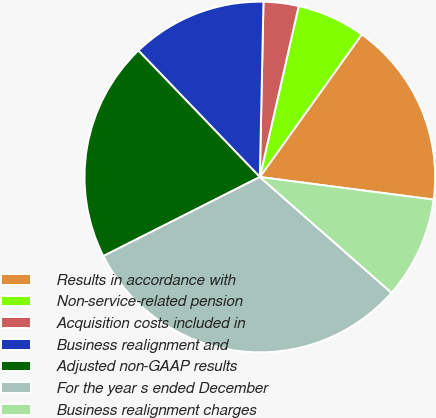<chart> <loc_0><loc_0><loc_500><loc_500><pie_chart><fcel>Results in accordance with<fcel>Non-service-related pension<fcel>Acquisition costs included in<fcel>Business realignment and<fcel>Adjusted non-GAAP results<fcel>For the year s ended December<fcel>Business realignment charges<nl><fcel>17.18%<fcel>6.32%<fcel>3.23%<fcel>12.51%<fcel>20.27%<fcel>31.08%<fcel>9.42%<nl></chart> 